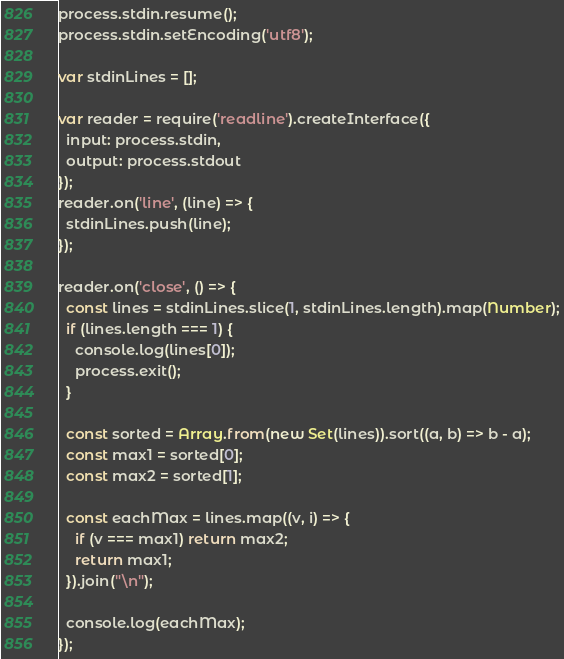Convert code to text. <code><loc_0><loc_0><loc_500><loc_500><_JavaScript_>process.stdin.resume();
process.stdin.setEncoding('utf8');

var stdinLines = [];

var reader = require('readline').createInterface({
  input: process.stdin,
  output: process.stdout
});
reader.on('line', (line) => {
  stdinLines.push(line);
});

reader.on('close', () => {
  const lines = stdinLines.slice(1, stdinLines.length).map(Number);
  if (lines.length === 1) {
    console.log(lines[0]);
    process.exit();
  }

  const sorted = Array.from(new Set(lines)).sort((a, b) => b - a);
  const max1 = sorted[0];
  const max2 = sorted[1];

  const eachMax = lines.map((v, i) => {
    if (v === max1) return max2;
    return max1;
  }).join("\n");

  console.log(eachMax);
});
</code> 